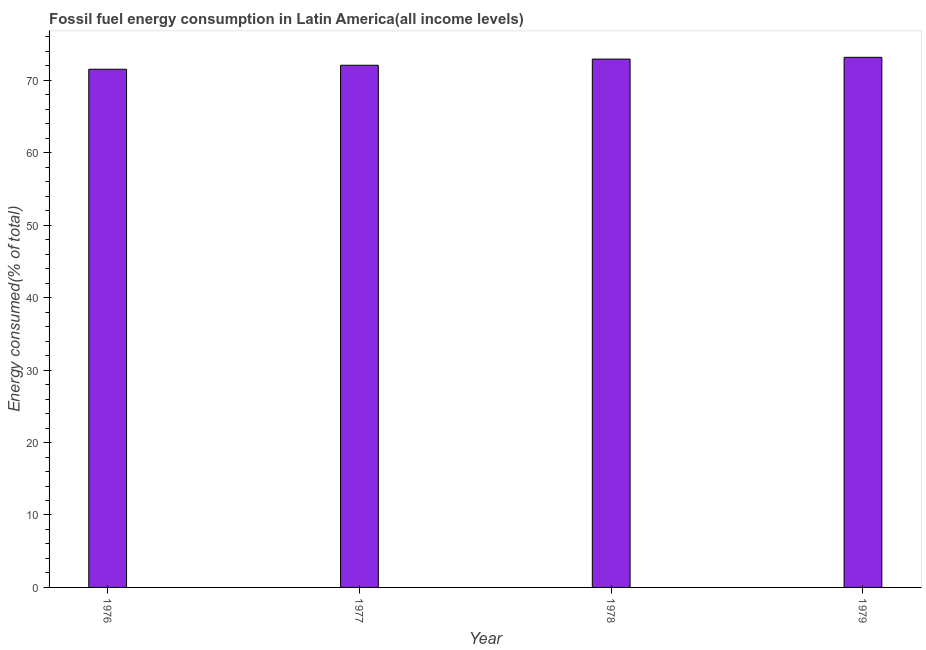Does the graph contain grids?
Your answer should be very brief. No. What is the title of the graph?
Give a very brief answer. Fossil fuel energy consumption in Latin America(all income levels). What is the label or title of the Y-axis?
Offer a very short reply. Energy consumed(% of total). What is the fossil fuel energy consumption in 1979?
Offer a very short reply. 73.18. Across all years, what is the maximum fossil fuel energy consumption?
Offer a terse response. 73.18. Across all years, what is the minimum fossil fuel energy consumption?
Provide a succinct answer. 71.54. In which year was the fossil fuel energy consumption maximum?
Your answer should be compact. 1979. In which year was the fossil fuel energy consumption minimum?
Your answer should be compact. 1976. What is the sum of the fossil fuel energy consumption?
Provide a short and direct response. 289.74. What is the difference between the fossil fuel energy consumption in 1976 and 1979?
Give a very brief answer. -1.65. What is the average fossil fuel energy consumption per year?
Offer a terse response. 72.44. What is the median fossil fuel energy consumption?
Give a very brief answer. 72.51. Do a majority of the years between 1976 and 1978 (inclusive) have fossil fuel energy consumption greater than 44 %?
Ensure brevity in your answer.  Yes. What is the ratio of the fossil fuel energy consumption in 1977 to that in 1979?
Ensure brevity in your answer.  0.98. What is the difference between the highest and the second highest fossil fuel energy consumption?
Make the answer very short. 0.24. What is the difference between the highest and the lowest fossil fuel energy consumption?
Your answer should be compact. 1.65. In how many years, is the fossil fuel energy consumption greater than the average fossil fuel energy consumption taken over all years?
Your response must be concise. 2. Are all the bars in the graph horizontal?
Provide a short and direct response. No. What is the difference between two consecutive major ticks on the Y-axis?
Give a very brief answer. 10. What is the Energy consumed(% of total) in 1976?
Your response must be concise. 71.54. What is the Energy consumed(% of total) of 1977?
Your response must be concise. 72.09. What is the Energy consumed(% of total) of 1978?
Your response must be concise. 72.94. What is the Energy consumed(% of total) of 1979?
Give a very brief answer. 73.18. What is the difference between the Energy consumed(% of total) in 1976 and 1977?
Offer a terse response. -0.55. What is the difference between the Energy consumed(% of total) in 1976 and 1978?
Your answer should be very brief. -1.4. What is the difference between the Energy consumed(% of total) in 1976 and 1979?
Provide a succinct answer. -1.65. What is the difference between the Energy consumed(% of total) in 1977 and 1978?
Give a very brief answer. -0.85. What is the difference between the Energy consumed(% of total) in 1977 and 1979?
Ensure brevity in your answer.  -1.09. What is the difference between the Energy consumed(% of total) in 1978 and 1979?
Keep it short and to the point. -0.24. What is the ratio of the Energy consumed(% of total) in 1976 to that in 1979?
Provide a short and direct response. 0.98. What is the ratio of the Energy consumed(% of total) in 1977 to that in 1978?
Provide a succinct answer. 0.99. 